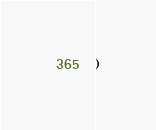Convert code to text. <code><loc_0><loc_0><loc_500><loc_500><_Clojure_>)
</code> 